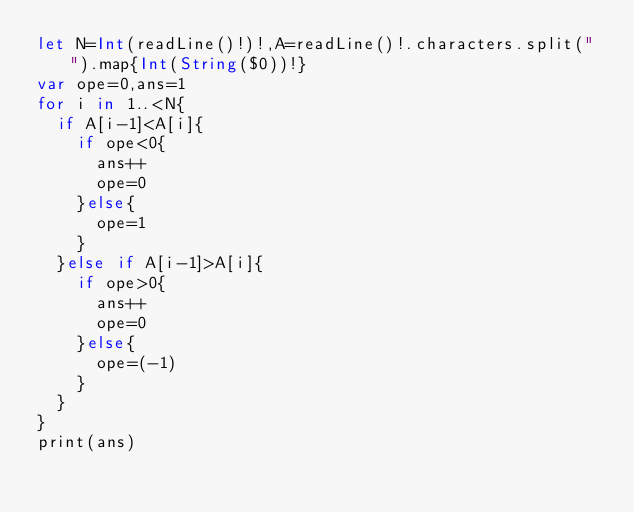Convert code to text. <code><loc_0><loc_0><loc_500><loc_500><_Swift_>let N=Int(readLine()!)!,A=readLine()!.characters.split(" ").map{Int(String($0))!}
var ope=0,ans=1
for i in 1..<N{
  if A[i-1]<A[i]{
    if ope<0{
      ans++
      ope=0
    }else{
      ope=1
    }
  }else if A[i-1]>A[i]{
    if ope>0{
      ans++
      ope=0
    }else{
      ope=(-1)
    }
  }
}
print(ans) </code> 